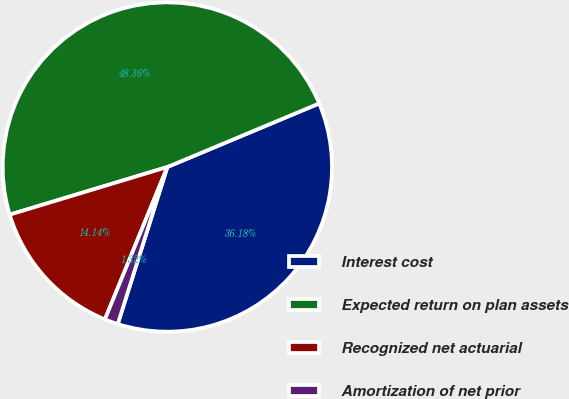Convert chart to OTSL. <chart><loc_0><loc_0><loc_500><loc_500><pie_chart><fcel>Interest cost<fcel>Expected return on plan assets<fcel>Recognized net actuarial<fcel>Amortization of net prior<nl><fcel>36.18%<fcel>48.36%<fcel>14.14%<fcel>1.32%<nl></chart> 